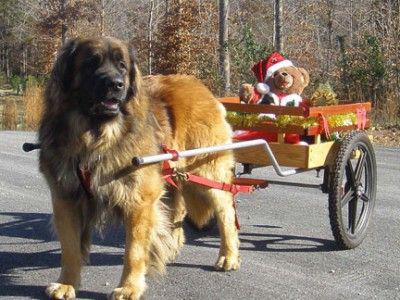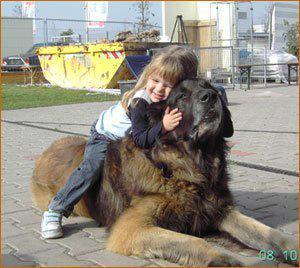The first image is the image on the left, the second image is the image on the right. For the images displayed, is the sentence "There is one dog lying on the ground in the image on the right." factually correct? Answer yes or no. Yes. The first image is the image on the left, the second image is the image on the right. Given the left and right images, does the statement "A little girl is holding a  large dog in the rightmost image." hold true? Answer yes or no. Yes. 